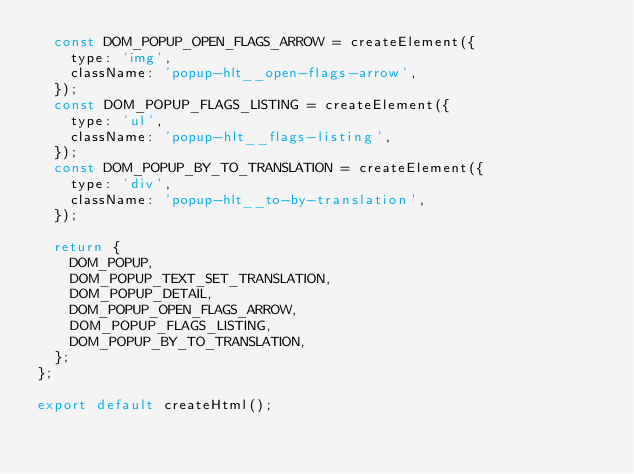<code> <loc_0><loc_0><loc_500><loc_500><_JavaScript_>  const DOM_POPUP_OPEN_FLAGS_ARROW = createElement({
    type: 'img',
    className: 'popup-hlt__open-flags-arrow',
  });
  const DOM_POPUP_FLAGS_LISTING = createElement({
    type: 'ul',
    className: 'popup-hlt__flags-listing',
  });
  const DOM_POPUP_BY_TO_TRANSLATION = createElement({
    type: 'div',
    className: 'popup-hlt__to-by-translation',
  });

  return {
    DOM_POPUP,
    DOM_POPUP_TEXT_SET_TRANSLATION,
    DOM_POPUP_DETAIL,
    DOM_POPUP_OPEN_FLAGS_ARROW,
    DOM_POPUP_FLAGS_LISTING,
    DOM_POPUP_BY_TO_TRANSLATION,
  };
};

export default createHtml();
</code> 